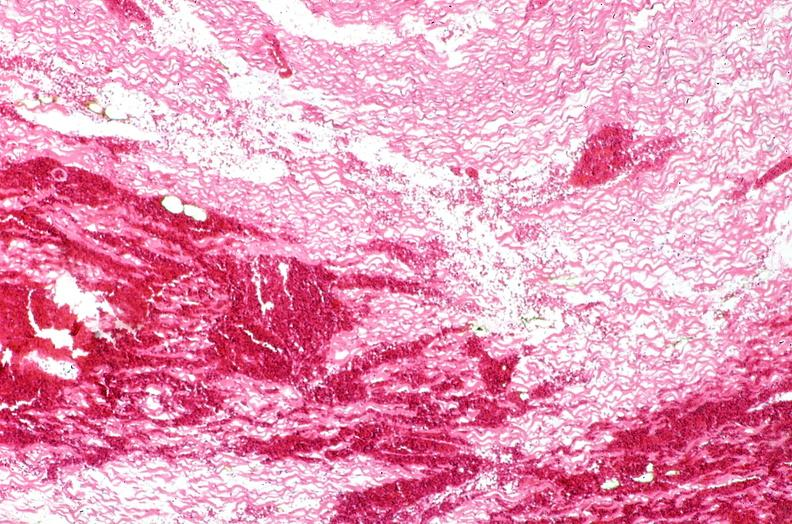s this typical lesion present?
Answer the question using a single word or phrase. No 